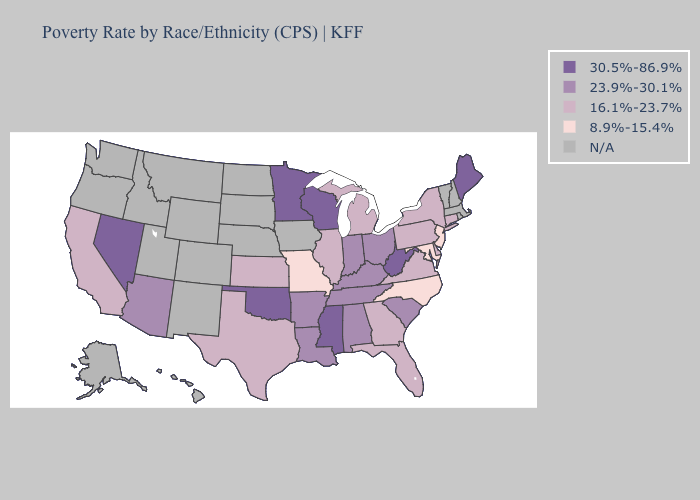Does New Jersey have the lowest value in the USA?
Be succinct. Yes. What is the lowest value in the MidWest?
Keep it brief. 8.9%-15.4%. How many symbols are there in the legend?
Give a very brief answer. 5. Does California have the highest value in the West?
Keep it brief. No. What is the value of Wyoming?
Give a very brief answer. N/A. Which states have the highest value in the USA?
Keep it brief. Maine, Minnesota, Mississippi, Nevada, Oklahoma, West Virginia, Wisconsin. Name the states that have a value in the range N/A?
Write a very short answer. Alaska, Colorado, Hawaii, Idaho, Iowa, Massachusetts, Montana, Nebraska, New Hampshire, New Mexico, North Dakota, Oregon, Rhode Island, South Dakota, Utah, Vermont, Washington, Wyoming. Does Minnesota have the highest value in the MidWest?
Answer briefly. Yes. What is the value of Georgia?
Answer briefly. 16.1%-23.7%. What is the value of Oregon?
Keep it brief. N/A. Which states hav the highest value in the MidWest?
Be succinct. Minnesota, Wisconsin. Does New York have the highest value in the Northeast?
Short answer required. No. What is the highest value in the USA?
Be succinct. 30.5%-86.9%. 